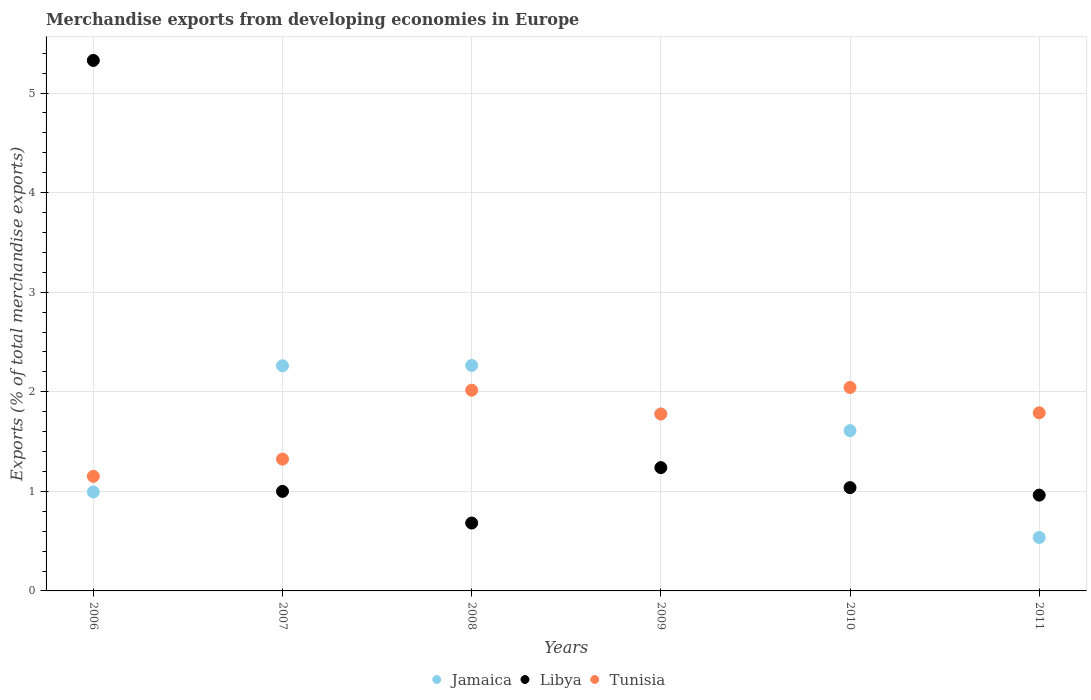What is the percentage of total merchandise exports in Libya in 2008?
Give a very brief answer. 0.68. Across all years, what is the maximum percentage of total merchandise exports in Jamaica?
Your answer should be compact. 2.26. Across all years, what is the minimum percentage of total merchandise exports in Libya?
Give a very brief answer. 0.68. In which year was the percentage of total merchandise exports in Tunisia maximum?
Offer a very short reply. 2010. In which year was the percentage of total merchandise exports in Jamaica minimum?
Offer a very short reply. 2011. What is the total percentage of total merchandise exports in Tunisia in the graph?
Provide a succinct answer. 10.1. What is the difference between the percentage of total merchandise exports in Tunisia in 2006 and that in 2011?
Your answer should be very brief. -0.64. What is the difference between the percentage of total merchandise exports in Jamaica in 2006 and the percentage of total merchandise exports in Tunisia in 2009?
Offer a terse response. -0.78. What is the average percentage of total merchandise exports in Tunisia per year?
Your answer should be compact. 1.68. In the year 2009, what is the difference between the percentage of total merchandise exports in Libya and percentage of total merchandise exports in Jamaica?
Offer a terse response. -0.54. In how many years, is the percentage of total merchandise exports in Libya greater than 4.2 %?
Keep it short and to the point. 1. What is the ratio of the percentage of total merchandise exports in Libya in 2006 to that in 2008?
Make the answer very short. 7.81. Is the percentage of total merchandise exports in Jamaica in 2006 less than that in 2008?
Keep it short and to the point. Yes. Is the difference between the percentage of total merchandise exports in Libya in 2009 and 2010 greater than the difference between the percentage of total merchandise exports in Jamaica in 2009 and 2010?
Your answer should be compact. Yes. What is the difference between the highest and the second highest percentage of total merchandise exports in Jamaica?
Your answer should be very brief. 0. What is the difference between the highest and the lowest percentage of total merchandise exports in Jamaica?
Give a very brief answer. 1.73. Is the sum of the percentage of total merchandise exports in Jamaica in 2010 and 2011 greater than the maximum percentage of total merchandise exports in Libya across all years?
Keep it short and to the point. No. Does the percentage of total merchandise exports in Libya monotonically increase over the years?
Make the answer very short. No. Is the percentage of total merchandise exports in Libya strictly less than the percentage of total merchandise exports in Tunisia over the years?
Provide a succinct answer. No. What is the difference between two consecutive major ticks on the Y-axis?
Offer a very short reply. 1. Does the graph contain any zero values?
Give a very brief answer. No. How many legend labels are there?
Offer a very short reply. 3. How are the legend labels stacked?
Make the answer very short. Horizontal. What is the title of the graph?
Provide a succinct answer. Merchandise exports from developing economies in Europe. Does "Yemen, Rep." appear as one of the legend labels in the graph?
Your answer should be compact. No. What is the label or title of the Y-axis?
Provide a short and direct response. Exports (% of total merchandise exports). What is the Exports (% of total merchandise exports) of Jamaica in 2006?
Make the answer very short. 0.99. What is the Exports (% of total merchandise exports) of Libya in 2006?
Offer a very short reply. 5.33. What is the Exports (% of total merchandise exports) in Tunisia in 2006?
Give a very brief answer. 1.15. What is the Exports (% of total merchandise exports) of Jamaica in 2007?
Your answer should be very brief. 2.26. What is the Exports (% of total merchandise exports) of Libya in 2007?
Ensure brevity in your answer.  1. What is the Exports (% of total merchandise exports) in Tunisia in 2007?
Provide a succinct answer. 1.32. What is the Exports (% of total merchandise exports) in Jamaica in 2008?
Offer a terse response. 2.26. What is the Exports (% of total merchandise exports) of Libya in 2008?
Offer a very short reply. 0.68. What is the Exports (% of total merchandise exports) in Tunisia in 2008?
Offer a very short reply. 2.02. What is the Exports (% of total merchandise exports) in Jamaica in 2009?
Make the answer very short. 1.78. What is the Exports (% of total merchandise exports) in Libya in 2009?
Offer a very short reply. 1.24. What is the Exports (% of total merchandise exports) of Tunisia in 2009?
Provide a succinct answer. 1.78. What is the Exports (% of total merchandise exports) in Jamaica in 2010?
Your answer should be very brief. 1.61. What is the Exports (% of total merchandise exports) in Libya in 2010?
Provide a short and direct response. 1.04. What is the Exports (% of total merchandise exports) of Tunisia in 2010?
Your answer should be very brief. 2.04. What is the Exports (% of total merchandise exports) of Jamaica in 2011?
Make the answer very short. 0.54. What is the Exports (% of total merchandise exports) of Libya in 2011?
Offer a terse response. 0.96. What is the Exports (% of total merchandise exports) of Tunisia in 2011?
Make the answer very short. 1.79. Across all years, what is the maximum Exports (% of total merchandise exports) in Jamaica?
Your response must be concise. 2.26. Across all years, what is the maximum Exports (% of total merchandise exports) of Libya?
Give a very brief answer. 5.33. Across all years, what is the maximum Exports (% of total merchandise exports) in Tunisia?
Ensure brevity in your answer.  2.04. Across all years, what is the minimum Exports (% of total merchandise exports) of Jamaica?
Keep it short and to the point. 0.54. Across all years, what is the minimum Exports (% of total merchandise exports) in Libya?
Give a very brief answer. 0.68. Across all years, what is the minimum Exports (% of total merchandise exports) in Tunisia?
Your response must be concise. 1.15. What is the total Exports (% of total merchandise exports) in Jamaica in the graph?
Offer a terse response. 9.44. What is the total Exports (% of total merchandise exports) of Libya in the graph?
Provide a succinct answer. 10.25. What is the total Exports (% of total merchandise exports) of Tunisia in the graph?
Offer a very short reply. 10.1. What is the difference between the Exports (% of total merchandise exports) of Jamaica in 2006 and that in 2007?
Ensure brevity in your answer.  -1.27. What is the difference between the Exports (% of total merchandise exports) in Libya in 2006 and that in 2007?
Offer a very short reply. 4.33. What is the difference between the Exports (% of total merchandise exports) of Tunisia in 2006 and that in 2007?
Ensure brevity in your answer.  -0.17. What is the difference between the Exports (% of total merchandise exports) in Jamaica in 2006 and that in 2008?
Make the answer very short. -1.27. What is the difference between the Exports (% of total merchandise exports) of Libya in 2006 and that in 2008?
Offer a very short reply. 4.65. What is the difference between the Exports (% of total merchandise exports) of Tunisia in 2006 and that in 2008?
Your answer should be compact. -0.86. What is the difference between the Exports (% of total merchandise exports) of Jamaica in 2006 and that in 2009?
Your answer should be very brief. -0.78. What is the difference between the Exports (% of total merchandise exports) in Libya in 2006 and that in 2009?
Offer a very short reply. 4.09. What is the difference between the Exports (% of total merchandise exports) of Tunisia in 2006 and that in 2009?
Provide a short and direct response. -0.63. What is the difference between the Exports (% of total merchandise exports) of Jamaica in 2006 and that in 2010?
Keep it short and to the point. -0.62. What is the difference between the Exports (% of total merchandise exports) in Libya in 2006 and that in 2010?
Ensure brevity in your answer.  4.29. What is the difference between the Exports (% of total merchandise exports) in Tunisia in 2006 and that in 2010?
Provide a succinct answer. -0.89. What is the difference between the Exports (% of total merchandise exports) in Jamaica in 2006 and that in 2011?
Keep it short and to the point. 0.46. What is the difference between the Exports (% of total merchandise exports) of Libya in 2006 and that in 2011?
Give a very brief answer. 4.37. What is the difference between the Exports (% of total merchandise exports) of Tunisia in 2006 and that in 2011?
Offer a terse response. -0.64. What is the difference between the Exports (% of total merchandise exports) in Jamaica in 2007 and that in 2008?
Your response must be concise. -0. What is the difference between the Exports (% of total merchandise exports) of Libya in 2007 and that in 2008?
Keep it short and to the point. 0.32. What is the difference between the Exports (% of total merchandise exports) in Tunisia in 2007 and that in 2008?
Give a very brief answer. -0.69. What is the difference between the Exports (% of total merchandise exports) in Jamaica in 2007 and that in 2009?
Make the answer very short. 0.48. What is the difference between the Exports (% of total merchandise exports) of Libya in 2007 and that in 2009?
Provide a short and direct response. -0.24. What is the difference between the Exports (% of total merchandise exports) in Tunisia in 2007 and that in 2009?
Provide a succinct answer. -0.45. What is the difference between the Exports (% of total merchandise exports) in Jamaica in 2007 and that in 2010?
Offer a terse response. 0.65. What is the difference between the Exports (% of total merchandise exports) of Libya in 2007 and that in 2010?
Provide a short and direct response. -0.04. What is the difference between the Exports (% of total merchandise exports) of Tunisia in 2007 and that in 2010?
Your answer should be very brief. -0.72. What is the difference between the Exports (% of total merchandise exports) in Jamaica in 2007 and that in 2011?
Offer a terse response. 1.72. What is the difference between the Exports (% of total merchandise exports) of Libya in 2007 and that in 2011?
Give a very brief answer. 0.04. What is the difference between the Exports (% of total merchandise exports) in Tunisia in 2007 and that in 2011?
Your answer should be very brief. -0.47. What is the difference between the Exports (% of total merchandise exports) in Jamaica in 2008 and that in 2009?
Offer a terse response. 0.49. What is the difference between the Exports (% of total merchandise exports) of Libya in 2008 and that in 2009?
Ensure brevity in your answer.  -0.56. What is the difference between the Exports (% of total merchandise exports) in Tunisia in 2008 and that in 2009?
Offer a terse response. 0.24. What is the difference between the Exports (% of total merchandise exports) in Jamaica in 2008 and that in 2010?
Ensure brevity in your answer.  0.65. What is the difference between the Exports (% of total merchandise exports) of Libya in 2008 and that in 2010?
Offer a terse response. -0.36. What is the difference between the Exports (% of total merchandise exports) of Tunisia in 2008 and that in 2010?
Offer a very short reply. -0.03. What is the difference between the Exports (% of total merchandise exports) of Jamaica in 2008 and that in 2011?
Give a very brief answer. 1.73. What is the difference between the Exports (% of total merchandise exports) in Libya in 2008 and that in 2011?
Give a very brief answer. -0.28. What is the difference between the Exports (% of total merchandise exports) of Tunisia in 2008 and that in 2011?
Your answer should be compact. 0.23. What is the difference between the Exports (% of total merchandise exports) in Jamaica in 2009 and that in 2010?
Your answer should be compact. 0.17. What is the difference between the Exports (% of total merchandise exports) in Libya in 2009 and that in 2010?
Give a very brief answer. 0.2. What is the difference between the Exports (% of total merchandise exports) in Tunisia in 2009 and that in 2010?
Your answer should be very brief. -0.27. What is the difference between the Exports (% of total merchandise exports) in Jamaica in 2009 and that in 2011?
Ensure brevity in your answer.  1.24. What is the difference between the Exports (% of total merchandise exports) of Libya in 2009 and that in 2011?
Offer a terse response. 0.28. What is the difference between the Exports (% of total merchandise exports) of Tunisia in 2009 and that in 2011?
Give a very brief answer. -0.01. What is the difference between the Exports (% of total merchandise exports) in Jamaica in 2010 and that in 2011?
Provide a succinct answer. 1.07. What is the difference between the Exports (% of total merchandise exports) in Libya in 2010 and that in 2011?
Keep it short and to the point. 0.08. What is the difference between the Exports (% of total merchandise exports) of Tunisia in 2010 and that in 2011?
Offer a very short reply. 0.25. What is the difference between the Exports (% of total merchandise exports) in Jamaica in 2006 and the Exports (% of total merchandise exports) in Libya in 2007?
Your response must be concise. -0.01. What is the difference between the Exports (% of total merchandise exports) in Jamaica in 2006 and the Exports (% of total merchandise exports) in Tunisia in 2007?
Ensure brevity in your answer.  -0.33. What is the difference between the Exports (% of total merchandise exports) in Libya in 2006 and the Exports (% of total merchandise exports) in Tunisia in 2007?
Your answer should be very brief. 4. What is the difference between the Exports (% of total merchandise exports) in Jamaica in 2006 and the Exports (% of total merchandise exports) in Libya in 2008?
Your answer should be compact. 0.31. What is the difference between the Exports (% of total merchandise exports) in Jamaica in 2006 and the Exports (% of total merchandise exports) in Tunisia in 2008?
Provide a succinct answer. -1.02. What is the difference between the Exports (% of total merchandise exports) of Libya in 2006 and the Exports (% of total merchandise exports) of Tunisia in 2008?
Give a very brief answer. 3.31. What is the difference between the Exports (% of total merchandise exports) of Jamaica in 2006 and the Exports (% of total merchandise exports) of Libya in 2009?
Your answer should be very brief. -0.24. What is the difference between the Exports (% of total merchandise exports) in Jamaica in 2006 and the Exports (% of total merchandise exports) in Tunisia in 2009?
Provide a short and direct response. -0.78. What is the difference between the Exports (% of total merchandise exports) of Libya in 2006 and the Exports (% of total merchandise exports) of Tunisia in 2009?
Provide a succinct answer. 3.55. What is the difference between the Exports (% of total merchandise exports) of Jamaica in 2006 and the Exports (% of total merchandise exports) of Libya in 2010?
Your response must be concise. -0.04. What is the difference between the Exports (% of total merchandise exports) of Jamaica in 2006 and the Exports (% of total merchandise exports) of Tunisia in 2010?
Give a very brief answer. -1.05. What is the difference between the Exports (% of total merchandise exports) of Libya in 2006 and the Exports (% of total merchandise exports) of Tunisia in 2010?
Offer a terse response. 3.28. What is the difference between the Exports (% of total merchandise exports) of Jamaica in 2006 and the Exports (% of total merchandise exports) of Libya in 2011?
Provide a short and direct response. 0.03. What is the difference between the Exports (% of total merchandise exports) in Jamaica in 2006 and the Exports (% of total merchandise exports) in Tunisia in 2011?
Make the answer very short. -0.8. What is the difference between the Exports (% of total merchandise exports) in Libya in 2006 and the Exports (% of total merchandise exports) in Tunisia in 2011?
Your response must be concise. 3.54. What is the difference between the Exports (% of total merchandise exports) of Jamaica in 2007 and the Exports (% of total merchandise exports) of Libya in 2008?
Give a very brief answer. 1.58. What is the difference between the Exports (% of total merchandise exports) in Jamaica in 2007 and the Exports (% of total merchandise exports) in Tunisia in 2008?
Offer a very short reply. 0.25. What is the difference between the Exports (% of total merchandise exports) in Libya in 2007 and the Exports (% of total merchandise exports) in Tunisia in 2008?
Provide a short and direct response. -1.02. What is the difference between the Exports (% of total merchandise exports) of Jamaica in 2007 and the Exports (% of total merchandise exports) of Tunisia in 2009?
Provide a succinct answer. 0.48. What is the difference between the Exports (% of total merchandise exports) in Libya in 2007 and the Exports (% of total merchandise exports) in Tunisia in 2009?
Provide a succinct answer. -0.78. What is the difference between the Exports (% of total merchandise exports) of Jamaica in 2007 and the Exports (% of total merchandise exports) of Libya in 2010?
Your answer should be compact. 1.22. What is the difference between the Exports (% of total merchandise exports) of Jamaica in 2007 and the Exports (% of total merchandise exports) of Tunisia in 2010?
Offer a terse response. 0.22. What is the difference between the Exports (% of total merchandise exports) of Libya in 2007 and the Exports (% of total merchandise exports) of Tunisia in 2010?
Your answer should be very brief. -1.04. What is the difference between the Exports (% of total merchandise exports) of Jamaica in 2007 and the Exports (% of total merchandise exports) of Libya in 2011?
Give a very brief answer. 1.3. What is the difference between the Exports (% of total merchandise exports) of Jamaica in 2007 and the Exports (% of total merchandise exports) of Tunisia in 2011?
Give a very brief answer. 0.47. What is the difference between the Exports (% of total merchandise exports) in Libya in 2007 and the Exports (% of total merchandise exports) in Tunisia in 2011?
Ensure brevity in your answer.  -0.79. What is the difference between the Exports (% of total merchandise exports) in Jamaica in 2008 and the Exports (% of total merchandise exports) in Libya in 2009?
Offer a terse response. 1.03. What is the difference between the Exports (% of total merchandise exports) in Jamaica in 2008 and the Exports (% of total merchandise exports) in Tunisia in 2009?
Make the answer very short. 0.49. What is the difference between the Exports (% of total merchandise exports) of Libya in 2008 and the Exports (% of total merchandise exports) of Tunisia in 2009?
Make the answer very short. -1.1. What is the difference between the Exports (% of total merchandise exports) of Jamaica in 2008 and the Exports (% of total merchandise exports) of Libya in 2010?
Give a very brief answer. 1.23. What is the difference between the Exports (% of total merchandise exports) of Jamaica in 2008 and the Exports (% of total merchandise exports) of Tunisia in 2010?
Ensure brevity in your answer.  0.22. What is the difference between the Exports (% of total merchandise exports) of Libya in 2008 and the Exports (% of total merchandise exports) of Tunisia in 2010?
Provide a short and direct response. -1.36. What is the difference between the Exports (% of total merchandise exports) of Jamaica in 2008 and the Exports (% of total merchandise exports) of Libya in 2011?
Offer a very short reply. 1.3. What is the difference between the Exports (% of total merchandise exports) in Jamaica in 2008 and the Exports (% of total merchandise exports) in Tunisia in 2011?
Ensure brevity in your answer.  0.48. What is the difference between the Exports (% of total merchandise exports) in Libya in 2008 and the Exports (% of total merchandise exports) in Tunisia in 2011?
Make the answer very short. -1.11. What is the difference between the Exports (% of total merchandise exports) of Jamaica in 2009 and the Exports (% of total merchandise exports) of Libya in 2010?
Keep it short and to the point. 0.74. What is the difference between the Exports (% of total merchandise exports) of Jamaica in 2009 and the Exports (% of total merchandise exports) of Tunisia in 2010?
Provide a short and direct response. -0.27. What is the difference between the Exports (% of total merchandise exports) of Libya in 2009 and the Exports (% of total merchandise exports) of Tunisia in 2010?
Provide a succinct answer. -0.81. What is the difference between the Exports (% of total merchandise exports) of Jamaica in 2009 and the Exports (% of total merchandise exports) of Libya in 2011?
Provide a short and direct response. 0.81. What is the difference between the Exports (% of total merchandise exports) of Jamaica in 2009 and the Exports (% of total merchandise exports) of Tunisia in 2011?
Keep it short and to the point. -0.01. What is the difference between the Exports (% of total merchandise exports) in Libya in 2009 and the Exports (% of total merchandise exports) in Tunisia in 2011?
Keep it short and to the point. -0.55. What is the difference between the Exports (% of total merchandise exports) in Jamaica in 2010 and the Exports (% of total merchandise exports) in Libya in 2011?
Your answer should be very brief. 0.65. What is the difference between the Exports (% of total merchandise exports) in Jamaica in 2010 and the Exports (% of total merchandise exports) in Tunisia in 2011?
Offer a terse response. -0.18. What is the difference between the Exports (% of total merchandise exports) of Libya in 2010 and the Exports (% of total merchandise exports) of Tunisia in 2011?
Ensure brevity in your answer.  -0.75. What is the average Exports (% of total merchandise exports) in Jamaica per year?
Offer a terse response. 1.57. What is the average Exports (% of total merchandise exports) of Libya per year?
Provide a succinct answer. 1.71. What is the average Exports (% of total merchandise exports) of Tunisia per year?
Make the answer very short. 1.68. In the year 2006, what is the difference between the Exports (% of total merchandise exports) in Jamaica and Exports (% of total merchandise exports) in Libya?
Ensure brevity in your answer.  -4.33. In the year 2006, what is the difference between the Exports (% of total merchandise exports) of Jamaica and Exports (% of total merchandise exports) of Tunisia?
Your answer should be very brief. -0.16. In the year 2006, what is the difference between the Exports (% of total merchandise exports) of Libya and Exports (% of total merchandise exports) of Tunisia?
Keep it short and to the point. 4.18. In the year 2007, what is the difference between the Exports (% of total merchandise exports) in Jamaica and Exports (% of total merchandise exports) in Libya?
Your response must be concise. 1.26. In the year 2007, what is the difference between the Exports (% of total merchandise exports) of Jamaica and Exports (% of total merchandise exports) of Tunisia?
Your response must be concise. 0.94. In the year 2007, what is the difference between the Exports (% of total merchandise exports) in Libya and Exports (% of total merchandise exports) in Tunisia?
Offer a very short reply. -0.32. In the year 2008, what is the difference between the Exports (% of total merchandise exports) in Jamaica and Exports (% of total merchandise exports) in Libya?
Give a very brief answer. 1.58. In the year 2008, what is the difference between the Exports (% of total merchandise exports) of Jamaica and Exports (% of total merchandise exports) of Tunisia?
Provide a short and direct response. 0.25. In the year 2008, what is the difference between the Exports (% of total merchandise exports) in Libya and Exports (% of total merchandise exports) in Tunisia?
Your response must be concise. -1.33. In the year 2009, what is the difference between the Exports (% of total merchandise exports) in Jamaica and Exports (% of total merchandise exports) in Libya?
Offer a very short reply. 0.54. In the year 2009, what is the difference between the Exports (% of total merchandise exports) in Jamaica and Exports (% of total merchandise exports) in Tunisia?
Make the answer very short. 0. In the year 2009, what is the difference between the Exports (% of total merchandise exports) of Libya and Exports (% of total merchandise exports) of Tunisia?
Your answer should be compact. -0.54. In the year 2010, what is the difference between the Exports (% of total merchandise exports) in Jamaica and Exports (% of total merchandise exports) in Libya?
Your answer should be compact. 0.57. In the year 2010, what is the difference between the Exports (% of total merchandise exports) of Jamaica and Exports (% of total merchandise exports) of Tunisia?
Give a very brief answer. -0.43. In the year 2010, what is the difference between the Exports (% of total merchandise exports) in Libya and Exports (% of total merchandise exports) in Tunisia?
Offer a very short reply. -1.01. In the year 2011, what is the difference between the Exports (% of total merchandise exports) in Jamaica and Exports (% of total merchandise exports) in Libya?
Offer a terse response. -0.43. In the year 2011, what is the difference between the Exports (% of total merchandise exports) of Jamaica and Exports (% of total merchandise exports) of Tunisia?
Provide a short and direct response. -1.25. In the year 2011, what is the difference between the Exports (% of total merchandise exports) in Libya and Exports (% of total merchandise exports) in Tunisia?
Your answer should be very brief. -0.83. What is the ratio of the Exports (% of total merchandise exports) in Jamaica in 2006 to that in 2007?
Give a very brief answer. 0.44. What is the ratio of the Exports (% of total merchandise exports) in Libya in 2006 to that in 2007?
Offer a very short reply. 5.33. What is the ratio of the Exports (% of total merchandise exports) of Tunisia in 2006 to that in 2007?
Offer a terse response. 0.87. What is the ratio of the Exports (% of total merchandise exports) in Jamaica in 2006 to that in 2008?
Ensure brevity in your answer.  0.44. What is the ratio of the Exports (% of total merchandise exports) of Libya in 2006 to that in 2008?
Your answer should be very brief. 7.81. What is the ratio of the Exports (% of total merchandise exports) in Tunisia in 2006 to that in 2008?
Your answer should be compact. 0.57. What is the ratio of the Exports (% of total merchandise exports) of Jamaica in 2006 to that in 2009?
Your response must be concise. 0.56. What is the ratio of the Exports (% of total merchandise exports) of Libya in 2006 to that in 2009?
Offer a terse response. 4.3. What is the ratio of the Exports (% of total merchandise exports) of Tunisia in 2006 to that in 2009?
Your answer should be compact. 0.65. What is the ratio of the Exports (% of total merchandise exports) of Jamaica in 2006 to that in 2010?
Make the answer very short. 0.62. What is the ratio of the Exports (% of total merchandise exports) in Libya in 2006 to that in 2010?
Keep it short and to the point. 5.14. What is the ratio of the Exports (% of total merchandise exports) in Tunisia in 2006 to that in 2010?
Make the answer very short. 0.56. What is the ratio of the Exports (% of total merchandise exports) of Jamaica in 2006 to that in 2011?
Offer a very short reply. 1.85. What is the ratio of the Exports (% of total merchandise exports) of Libya in 2006 to that in 2011?
Ensure brevity in your answer.  5.54. What is the ratio of the Exports (% of total merchandise exports) of Tunisia in 2006 to that in 2011?
Ensure brevity in your answer.  0.64. What is the ratio of the Exports (% of total merchandise exports) of Jamaica in 2007 to that in 2008?
Provide a succinct answer. 1. What is the ratio of the Exports (% of total merchandise exports) of Libya in 2007 to that in 2008?
Provide a succinct answer. 1.47. What is the ratio of the Exports (% of total merchandise exports) in Tunisia in 2007 to that in 2008?
Keep it short and to the point. 0.66. What is the ratio of the Exports (% of total merchandise exports) of Jamaica in 2007 to that in 2009?
Ensure brevity in your answer.  1.27. What is the ratio of the Exports (% of total merchandise exports) in Libya in 2007 to that in 2009?
Your response must be concise. 0.81. What is the ratio of the Exports (% of total merchandise exports) of Tunisia in 2007 to that in 2009?
Give a very brief answer. 0.74. What is the ratio of the Exports (% of total merchandise exports) in Jamaica in 2007 to that in 2010?
Provide a succinct answer. 1.4. What is the ratio of the Exports (% of total merchandise exports) in Libya in 2007 to that in 2010?
Ensure brevity in your answer.  0.96. What is the ratio of the Exports (% of total merchandise exports) of Tunisia in 2007 to that in 2010?
Make the answer very short. 0.65. What is the ratio of the Exports (% of total merchandise exports) in Jamaica in 2007 to that in 2011?
Give a very brief answer. 4.21. What is the ratio of the Exports (% of total merchandise exports) in Libya in 2007 to that in 2011?
Your response must be concise. 1.04. What is the ratio of the Exports (% of total merchandise exports) in Tunisia in 2007 to that in 2011?
Offer a terse response. 0.74. What is the ratio of the Exports (% of total merchandise exports) of Jamaica in 2008 to that in 2009?
Provide a short and direct response. 1.27. What is the ratio of the Exports (% of total merchandise exports) of Libya in 2008 to that in 2009?
Ensure brevity in your answer.  0.55. What is the ratio of the Exports (% of total merchandise exports) of Tunisia in 2008 to that in 2009?
Make the answer very short. 1.13. What is the ratio of the Exports (% of total merchandise exports) in Jamaica in 2008 to that in 2010?
Offer a very short reply. 1.41. What is the ratio of the Exports (% of total merchandise exports) in Libya in 2008 to that in 2010?
Provide a short and direct response. 0.66. What is the ratio of the Exports (% of total merchandise exports) in Tunisia in 2008 to that in 2010?
Offer a terse response. 0.99. What is the ratio of the Exports (% of total merchandise exports) in Jamaica in 2008 to that in 2011?
Your answer should be very brief. 4.22. What is the ratio of the Exports (% of total merchandise exports) of Libya in 2008 to that in 2011?
Offer a very short reply. 0.71. What is the ratio of the Exports (% of total merchandise exports) in Tunisia in 2008 to that in 2011?
Make the answer very short. 1.13. What is the ratio of the Exports (% of total merchandise exports) in Jamaica in 2009 to that in 2010?
Your response must be concise. 1.1. What is the ratio of the Exports (% of total merchandise exports) in Libya in 2009 to that in 2010?
Make the answer very short. 1.19. What is the ratio of the Exports (% of total merchandise exports) of Tunisia in 2009 to that in 2010?
Offer a very short reply. 0.87. What is the ratio of the Exports (% of total merchandise exports) in Jamaica in 2009 to that in 2011?
Offer a very short reply. 3.31. What is the ratio of the Exports (% of total merchandise exports) of Libya in 2009 to that in 2011?
Make the answer very short. 1.29. What is the ratio of the Exports (% of total merchandise exports) of Jamaica in 2010 to that in 2011?
Offer a very short reply. 3. What is the ratio of the Exports (% of total merchandise exports) of Libya in 2010 to that in 2011?
Offer a very short reply. 1.08. What is the ratio of the Exports (% of total merchandise exports) in Tunisia in 2010 to that in 2011?
Offer a terse response. 1.14. What is the difference between the highest and the second highest Exports (% of total merchandise exports) of Jamaica?
Offer a terse response. 0. What is the difference between the highest and the second highest Exports (% of total merchandise exports) in Libya?
Keep it short and to the point. 4.09. What is the difference between the highest and the second highest Exports (% of total merchandise exports) in Tunisia?
Provide a succinct answer. 0.03. What is the difference between the highest and the lowest Exports (% of total merchandise exports) of Jamaica?
Ensure brevity in your answer.  1.73. What is the difference between the highest and the lowest Exports (% of total merchandise exports) of Libya?
Ensure brevity in your answer.  4.65. What is the difference between the highest and the lowest Exports (% of total merchandise exports) of Tunisia?
Ensure brevity in your answer.  0.89. 